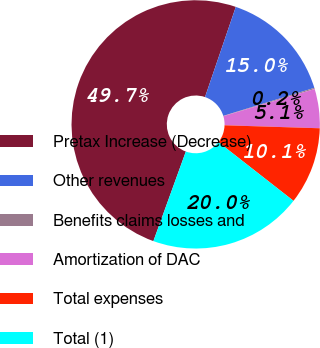<chart> <loc_0><loc_0><loc_500><loc_500><pie_chart><fcel>Pretax Increase (Decrease)<fcel>Other revenues<fcel>Benefits claims losses and<fcel>Amortization of DAC<fcel>Total expenses<fcel>Total (1)<nl><fcel>49.7%<fcel>15.01%<fcel>0.15%<fcel>5.1%<fcel>10.06%<fcel>19.97%<nl></chart> 